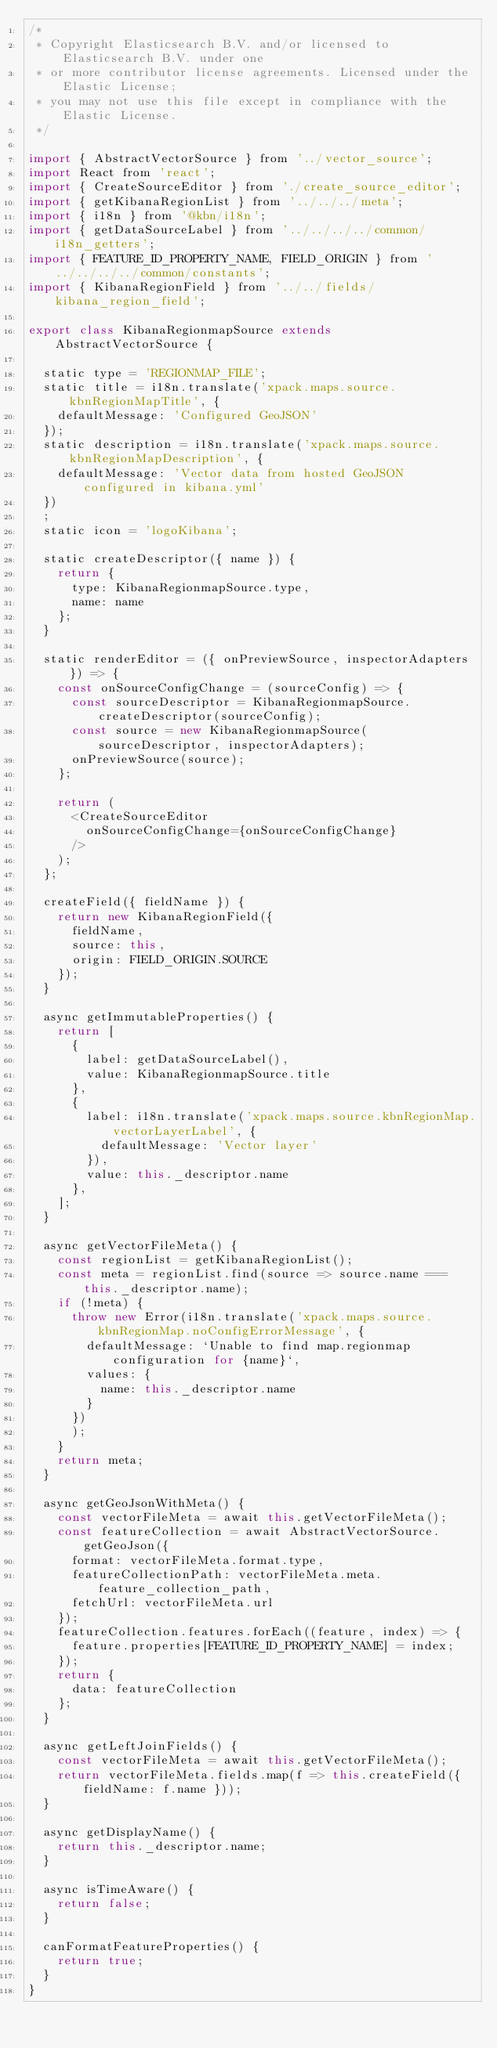Convert code to text. <code><loc_0><loc_0><loc_500><loc_500><_JavaScript_>/*
 * Copyright Elasticsearch B.V. and/or licensed to Elasticsearch B.V. under one
 * or more contributor license agreements. Licensed under the Elastic License;
 * you may not use this file except in compliance with the Elastic License.
 */

import { AbstractVectorSource } from '../vector_source';
import React from 'react';
import { CreateSourceEditor } from './create_source_editor';
import { getKibanaRegionList } from '../../../meta';
import { i18n } from '@kbn/i18n';
import { getDataSourceLabel } from '../../../../common/i18n_getters';
import { FEATURE_ID_PROPERTY_NAME, FIELD_ORIGIN } from '../../../../common/constants';
import { KibanaRegionField } from '../../fields/kibana_region_field';

export class KibanaRegionmapSource extends AbstractVectorSource {

  static type = 'REGIONMAP_FILE';
  static title = i18n.translate('xpack.maps.source.kbnRegionMapTitle', {
    defaultMessage: 'Configured GeoJSON'
  });
  static description = i18n.translate('xpack.maps.source.kbnRegionMapDescription', {
    defaultMessage: 'Vector data from hosted GeoJSON configured in kibana.yml'
  })
  ;
  static icon = 'logoKibana';

  static createDescriptor({ name }) {
    return {
      type: KibanaRegionmapSource.type,
      name: name
    };
  }

  static renderEditor = ({ onPreviewSource, inspectorAdapters }) => {
    const onSourceConfigChange = (sourceConfig) => {
      const sourceDescriptor = KibanaRegionmapSource.createDescriptor(sourceConfig);
      const source = new KibanaRegionmapSource(sourceDescriptor, inspectorAdapters);
      onPreviewSource(source);
    };

    return (
      <CreateSourceEditor
        onSourceConfigChange={onSourceConfigChange}
      />
    );
  };

  createField({ fieldName }) {
    return new KibanaRegionField({
      fieldName,
      source: this,
      origin: FIELD_ORIGIN.SOURCE
    });
  }

  async getImmutableProperties() {
    return [
      {
        label: getDataSourceLabel(),
        value: KibanaRegionmapSource.title
      },
      {
        label: i18n.translate('xpack.maps.source.kbnRegionMap.vectorLayerLabel', {
          defaultMessage: 'Vector layer'
        }),
        value: this._descriptor.name
      },
    ];
  }

  async getVectorFileMeta() {
    const regionList = getKibanaRegionList();
    const meta = regionList.find(source => source.name === this._descriptor.name);
    if (!meta) {
      throw new Error(i18n.translate('xpack.maps.source.kbnRegionMap.noConfigErrorMessage', {
        defaultMessage: `Unable to find map.regionmap configuration for {name}`,
        values: {
          name: this._descriptor.name
        }
      })
      );
    }
    return meta;
  }

  async getGeoJsonWithMeta() {
    const vectorFileMeta = await this.getVectorFileMeta();
    const featureCollection = await AbstractVectorSource.getGeoJson({
      format: vectorFileMeta.format.type,
      featureCollectionPath: vectorFileMeta.meta.feature_collection_path,
      fetchUrl: vectorFileMeta.url
    });
    featureCollection.features.forEach((feature, index) => {
      feature.properties[FEATURE_ID_PROPERTY_NAME] = index;
    });
    return {
      data: featureCollection
    };
  }

  async getLeftJoinFields() {
    const vectorFileMeta = await this.getVectorFileMeta();
    return vectorFileMeta.fields.map(f => this.createField({ fieldName: f.name }));
  }

  async getDisplayName() {
    return this._descriptor.name;
  }

  async isTimeAware() {
    return false;
  }

  canFormatFeatureProperties() {
    return true;
  }
}
</code> 